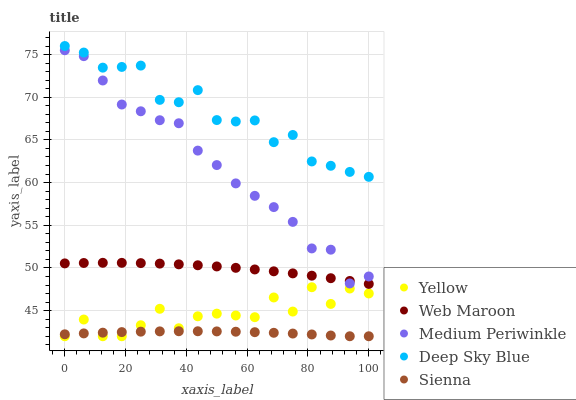Does Sienna have the minimum area under the curve?
Answer yes or no. Yes. Does Deep Sky Blue have the maximum area under the curve?
Answer yes or no. Yes. Does Medium Periwinkle have the minimum area under the curve?
Answer yes or no. No. Does Medium Periwinkle have the maximum area under the curve?
Answer yes or no. No. Is Sienna the smoothest?
Answer yes or no. Yes. Is Yellow the roughest?
Answer yes or no. Yes. Is Medium Periwinkle the smoothest?
Answer yes or no. No. Is Medium Periwinkle the roughest?
Answer yes or no. No. Does Sienna have the lowest value?
Answer yes or no. Yes. Does Medium Periwinkle have the lowest value?
Answer yes or no. No. Does Deep Sky Blue have the highest value?
Answer yes or no. Yes. Does Medium Periwinkle have the highest value?
Answer yes or no. No. Is Web Maroon less than Deep Sky Blue?
Answer yes or no. Yes. Is Medium Periwinkle greater than Yellow?
Answer yes or no. Yes. Does Sienna intersect Yellow?
Answer yes or no. Yes. Is Sienna less than Yellow?
Answer yes or no. No. Is Sienna greater than Yellow?
Answer yes or no. No. Does Web Maroon intersect Deep Sky Blue?
Answer yes or no. No. 